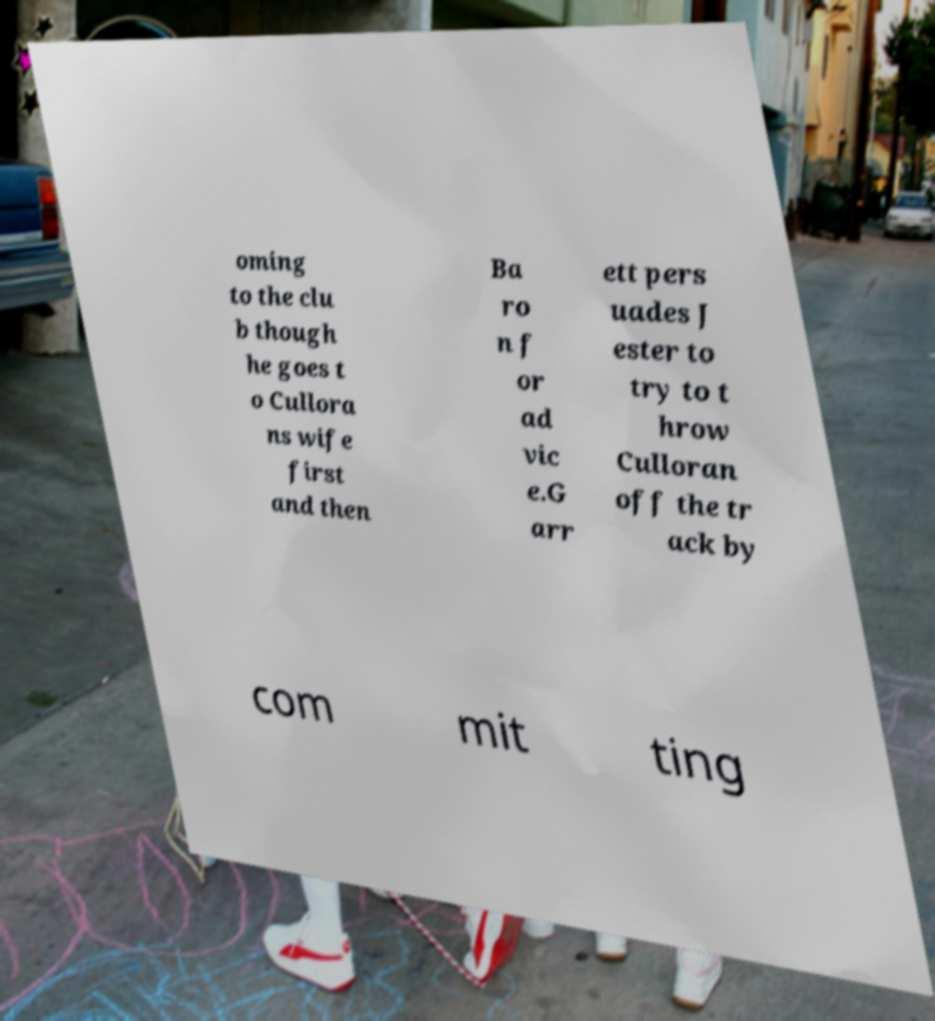What messages or text are displayed in this image? I need them in a readable, typed format. oming to the clu b though he goes t o Cullora ns wife first and then Ba ro n f or ad vic e.G arr ett pers uades J ester to try to t hrow Culloran off the tr ack by com mit ting 